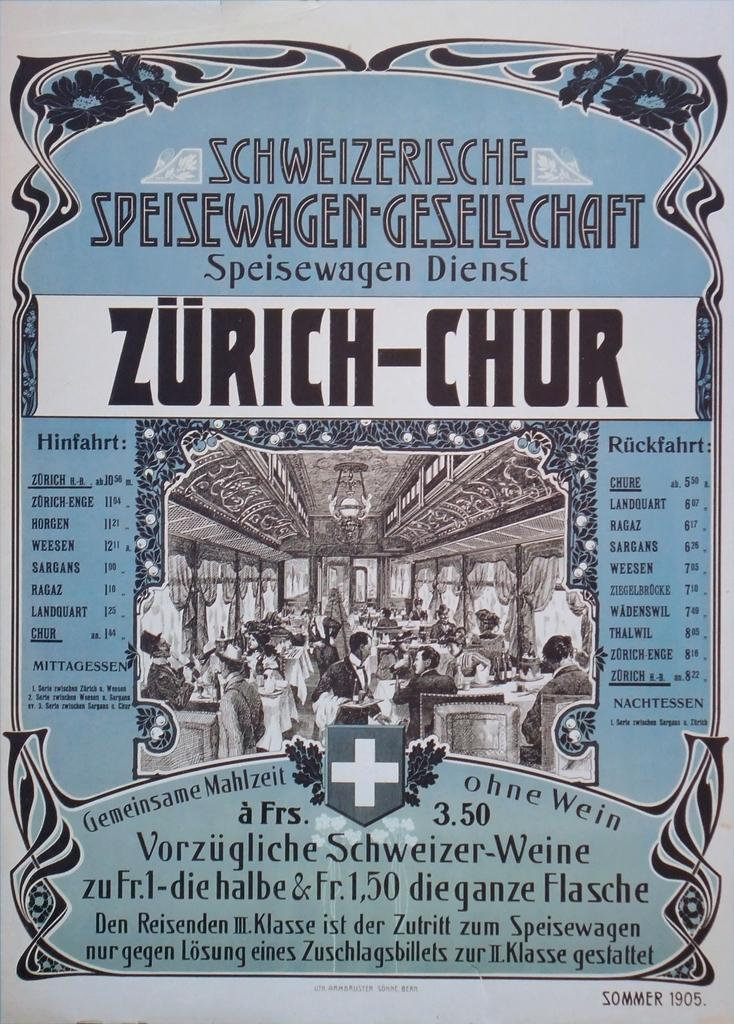Provide a one-sentence caption for the provided image. A very old Swiss menu lists prices of its offerings. 